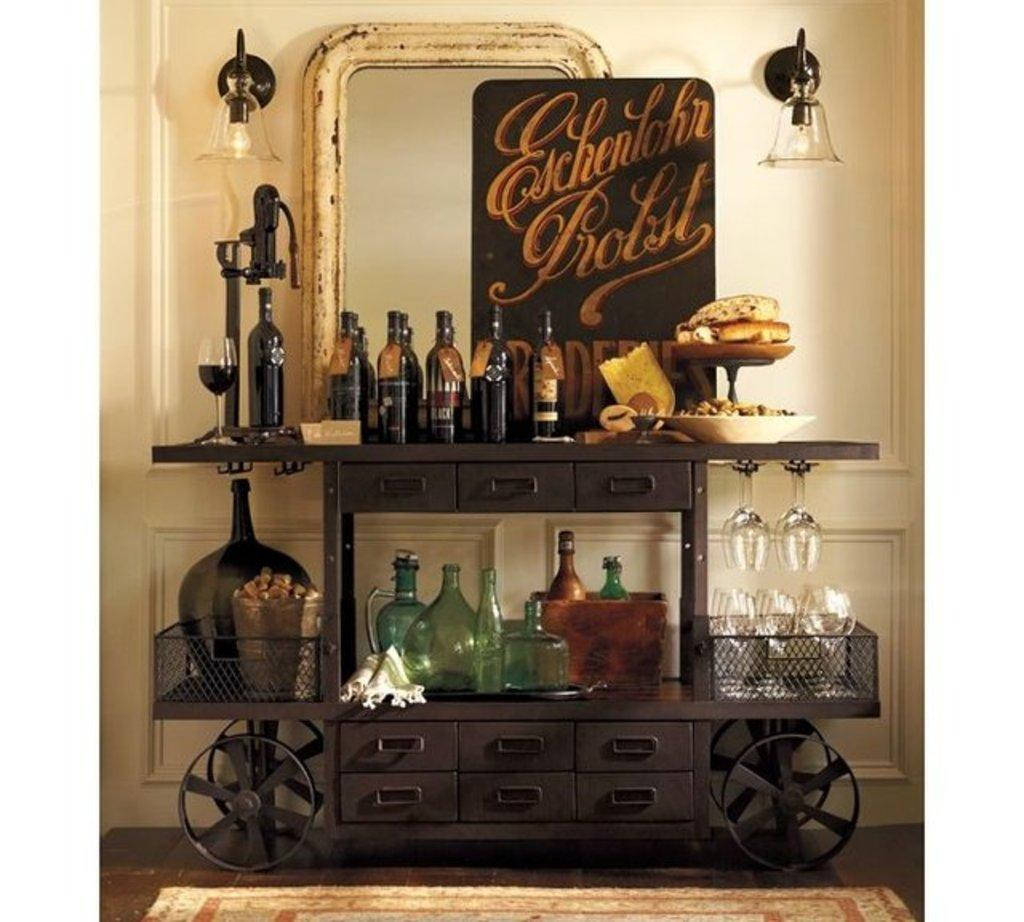<image>
Write a terse but informative summary of the picture. An Eschenlohr Probst sign sits in front of a mirror. 